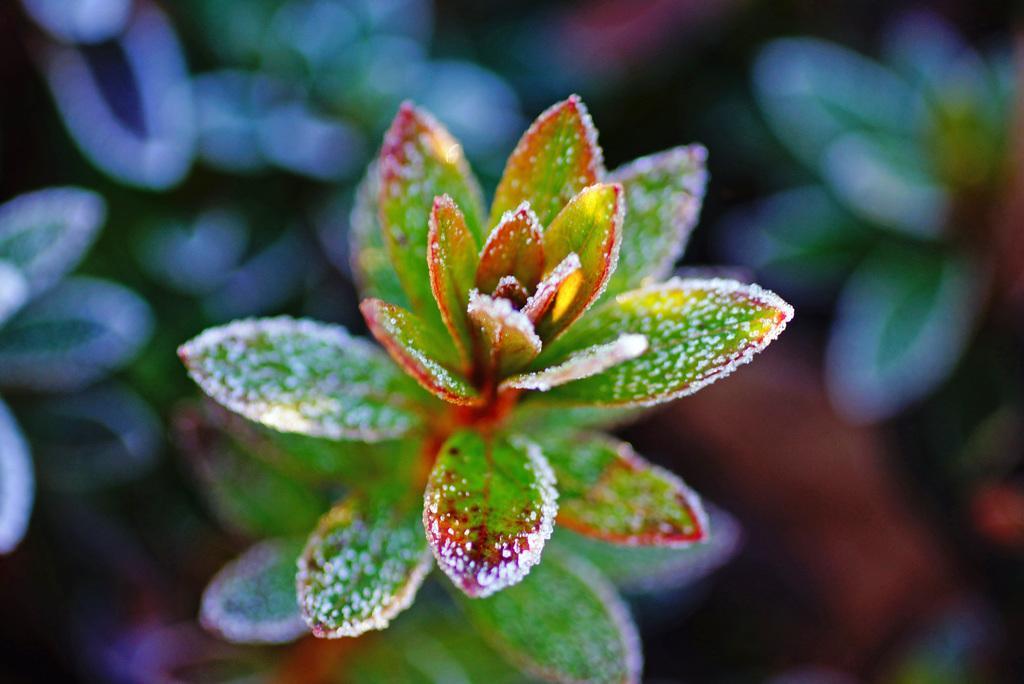Please provide a concise description of this image. In this image there are a few leaves of a plant. 